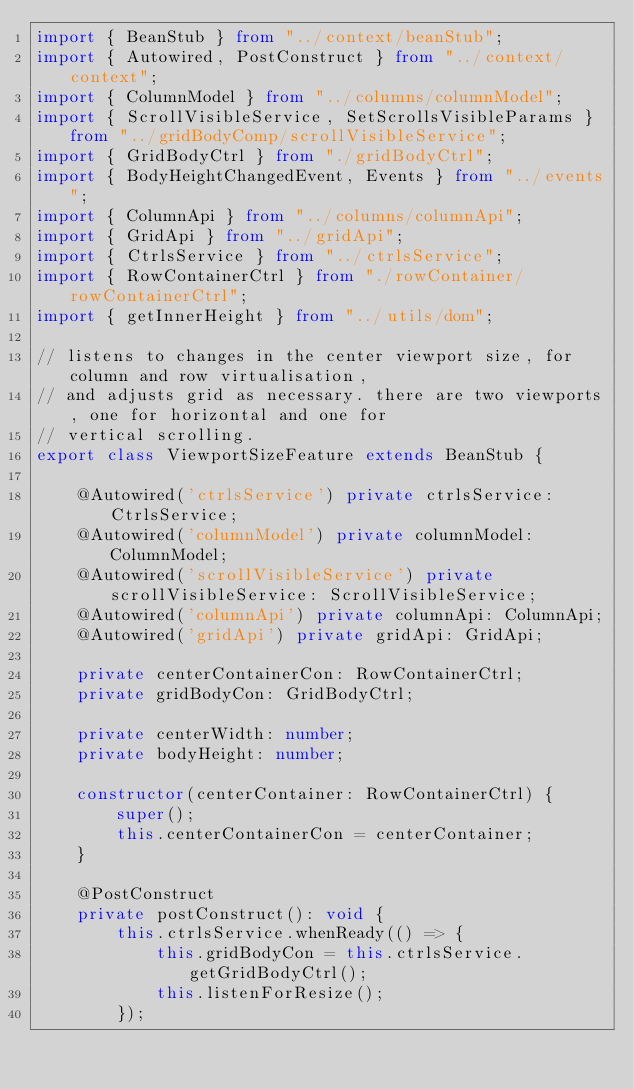<code> <loc_0><loc_0><loc_500><loc_500><_TypeScript_>import { BeanStub } from "../context/beanStub";
import { Autowired, PostConstruct } from "../context/context";
import { ColumnModel } from "../columns/columnModel";
import { ScrollVisibleService, SetScrollsVisibleParams } from "../gridBodyComp/scrollVisibleService";
import { GridBodyCtrl } from "./gridBodyCtrl";
import { BodyHeightChangedEvent, Events } from "../events";
import { ColumnApi } from "../columns/columnApi";
import { GridApi } from "../gridApi";
import { CtrlsService } from "../ctrlsService";
import { RowContainerCtrl } from "./rowContainer/rowContainerCtrl";
import { getInnerHeight } from "../utils/dom";

// listens to changes in the center viewport size, for column and row virtualisation,
// and adjusts grid as necessary. there are two viewports, one for horizontal and one for
// vertical scrolling.
export class ViewportSizeFeature extends BeanStub {

    @Autowired('ctrlsService') private ctrlsService: CtrlsService;
    @Autowired('columnModel') private columnModel: ColumnModel;
    @Autowired('scrollVisibleService') private scrollVisibleService: ScrollVisibleService;
    @Autowired('columnApi') private columnApi: ColumnApi;
    @Autowired('gridApi') private gridApi: GridApi;

    private centerContainerCon: RowContainerCtrl;
    private gridBodyCon: GridBodyCtrl;

    private centerWidth: number;
    private bodyHeight: number;

    constructor(centerContainer: RowContainerCtrl) {
        super();
        this.centerContainerCon = centerContainer;
    }

    @PostConstruct
    private postConstruct(): void {
        this.ctrlsService.whenReady(() => {
            this.gridBodyCon = this.ctrlsService.getGridBodyCtrl();
            this.listenForResize();
        });</code> 